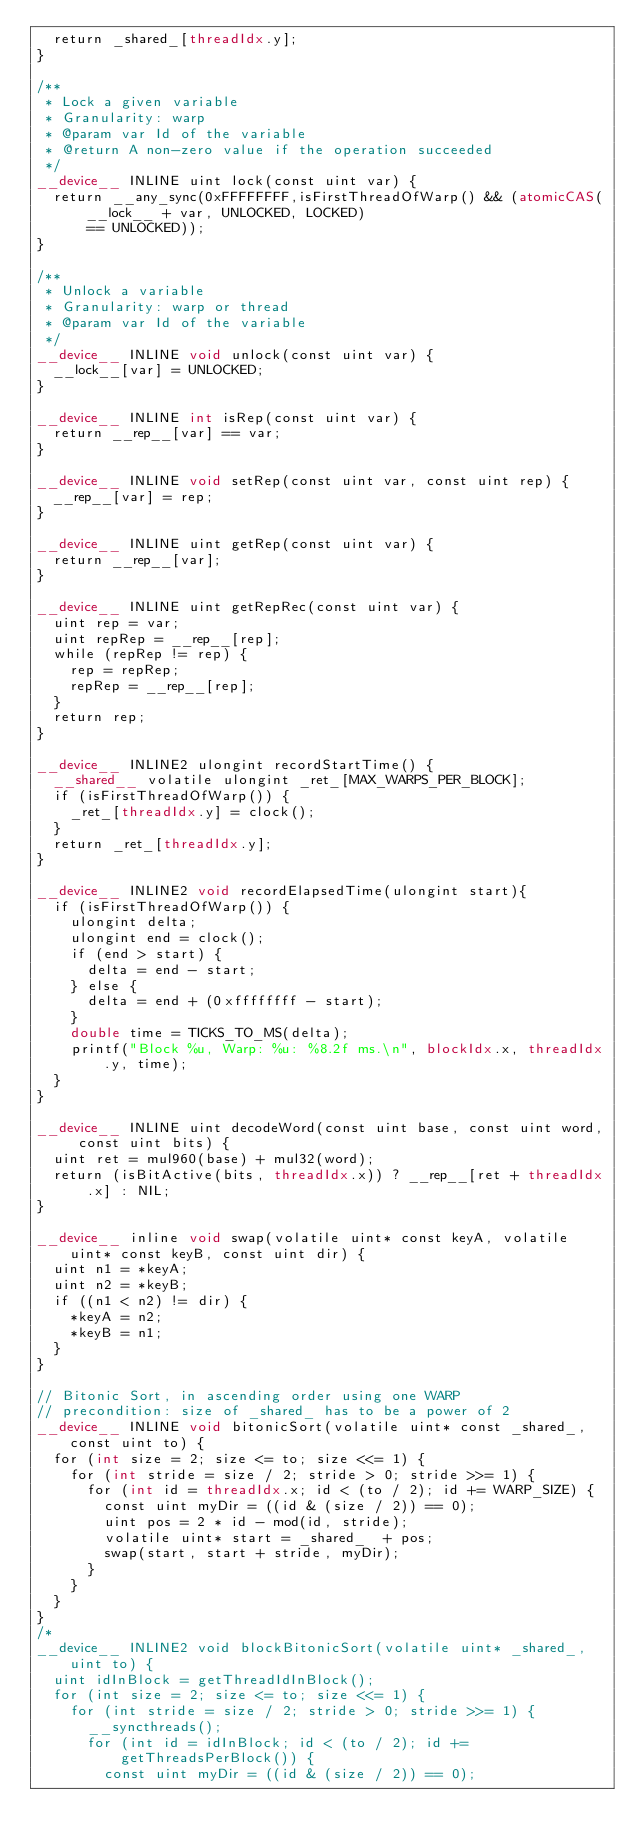<code> <loc_0><loc_0><loc_500><loc_500><_Cuda_>  return _shared_[threadIdx.y];
}

/**
 * Lock a given variable 
 * Granularity: warp
 * @param var Id of the variable
 * @return A non-zero value if the operation succeeded
 */
__device__ INLINE uint lock(const uint var) {
  return __any_sync(0xFFFFFFFF,isFirstThreadOfWarp() && (atomicCAS(__lock__ + var, UNLOCKED, LOCKED) 
      == UNLOCKED));
}

/**
 * Unlock a variable
 * Granularity: warp or thread
 * @param var Id of the variable
 */
__device__ INLINE void unlock(const uint var) {
  __lock__[var] = UNLOCKED;
}

__device__ INLINE int isRep(const uint var) {
  return __rep__[var] == var;
}

__device__ INLINE void setRep(const uint var, const uint rep) {
  __rep__[var] = rep;
}

__device__ INLINE uint getRep(const uint var) {
  return __rep__[var];
}

__device__ INLINE uint getRepRec(const uint var) {
  uint rep = var;
  uint repRep = __rep__[rep];
  while (repRep != rep) {
    rep = repRep;
    repRep = __rep__[rep];
  } 
  return rep;
}

__device__ INLINE2 ulongint recordStartTime() {
  __shared__ volatile ulongint _ret_[MAX_WARPS_PER_BLOCK];
  if (isFirstThreadOfWarp()) {
    _ret_[threadIdx.y] = clock();
  }
  return _ret_[threadIdx.y];
}

__device__ INLINE2 void recordElapsedTime(ulongint start){
  if (isFirstThreadOfWarp()) {
    ulongint delta;
    ulongint end = clock();
    if (end > start) {
      delta = end - start;
    } else {
      delta = end + (0xffffffff - start);
    }
    double time = TICKS_TO_MS(delta);
    printf("Block %u, Warp: %u: %8.2f ms.\n", blockIdx.x, threadIdx.y, time);
  }
}

__device__ INLINE uint decodeWord(const uint base, const uint word, const uint bits) {
  uint ret = mul960(base) + mul32(word);
  return (isBitActive(bits, threadIdx.x)) ? __rep__[ret + threadIdx.x] : NIL;
}

__device__ inline void swap(volatile uint* const keyA, volatile uint* const keyB, const uint dir) {
  uint n1 = *keyA;
  uint n2 = *keyB;
  if ((n1 < n2) != dir) {
    *keyA = n2;
    *keyB = n1;
  }
}

// Bitonic Sort, in ascending order using one WARP
// precondition: size of _shared_ has to be a power of 2
__device__ INLINE void bitonicSort(volatile uint* const _shared_, const uint to) {
  for (int size = 2; size <= to; size <<= 1) {
    for (int stride = size / 2; stride > 0; stride >>= 1) {
      for (int id = threadIdx.x; id < (to / 2); id += WARP_SIZE) {
        const uint myDir = ((id & (size / 2)) == 0);
        uint pos = 2 * id - mod(id, stride);
        volatile uint* start = _shared_  + pos;
        swap(start, start + stride, myDir);
      }
    }
  }
}
/*
__device__ INLINE2 void blockBitonicSort(volatile uint* _shared_, uint to) {
  uint idInBlock = getThreadIdInBlock();
  for (int size = 2; size <= to; size <<= 1) {
    for (int stride = size / 2; stride > 0; stride >>= 1) {
      __syncthreads();
      for (int id = idInBlock; id < (to / 2); id += getThreadsPerBlock()) {
        const uint myDir = ((id & (size / 2)) == 0);</code> 